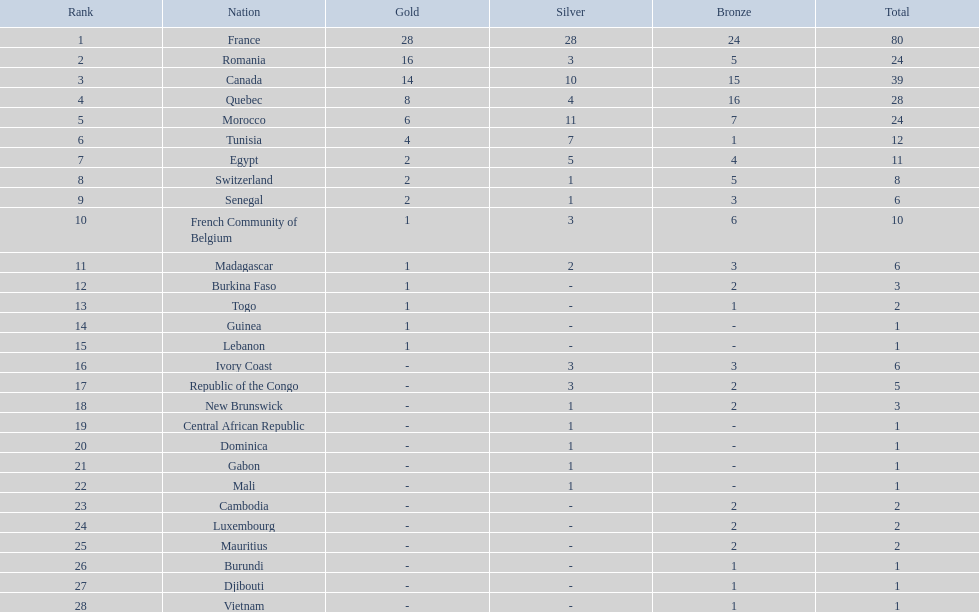How many nations won at least 10 medals? 8. 